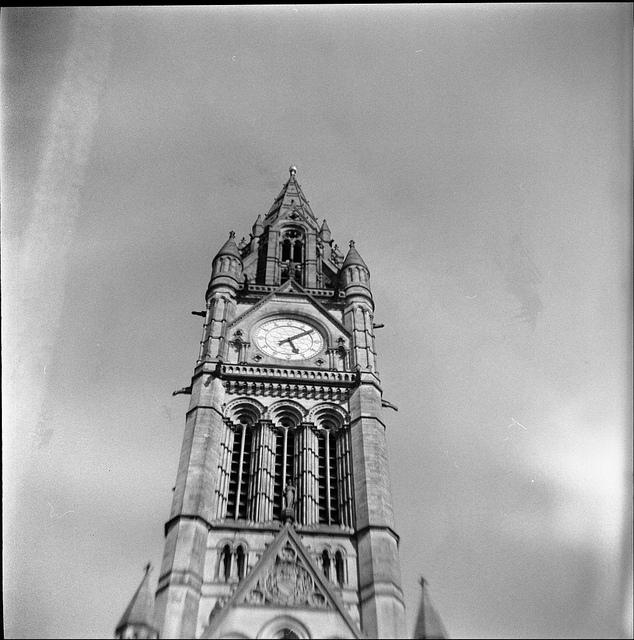Was this picture taken through a window?
Concise answer only. Yes. Is this the top of a tower?
Quick response, please. Yes. What time is on the clock tower?
Be succinct. 5:10. 